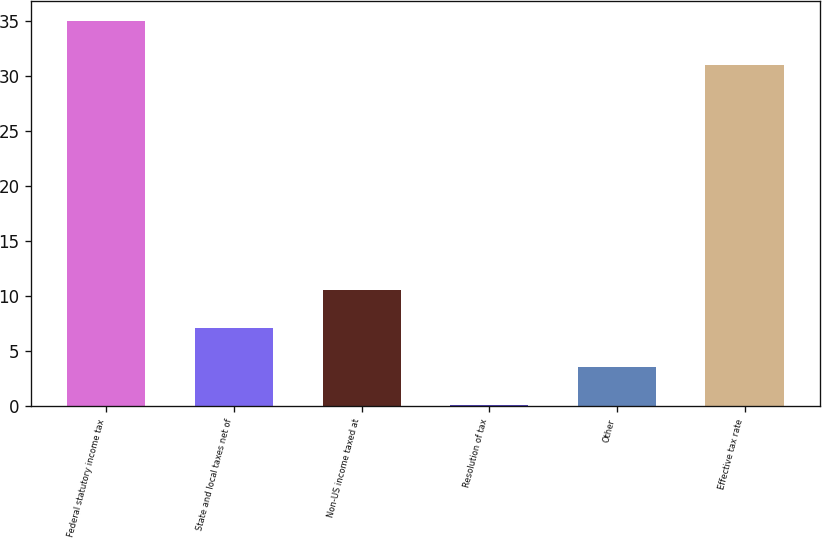<chart> <loc_0><loc_0><loc_500><loc_500><bar_chart><fcel>Federal statutory income tax<fcel>State and local taxes net of<fcel>Non-US income taxed at<fcel>Resolution of tax<fcel>Other<fcel>Effective tax rate<nl><fcel>35<fcel>7.08<fcel>10.57<fcel>0.1<fcel>3.59<fcel>31<nl></chart> 